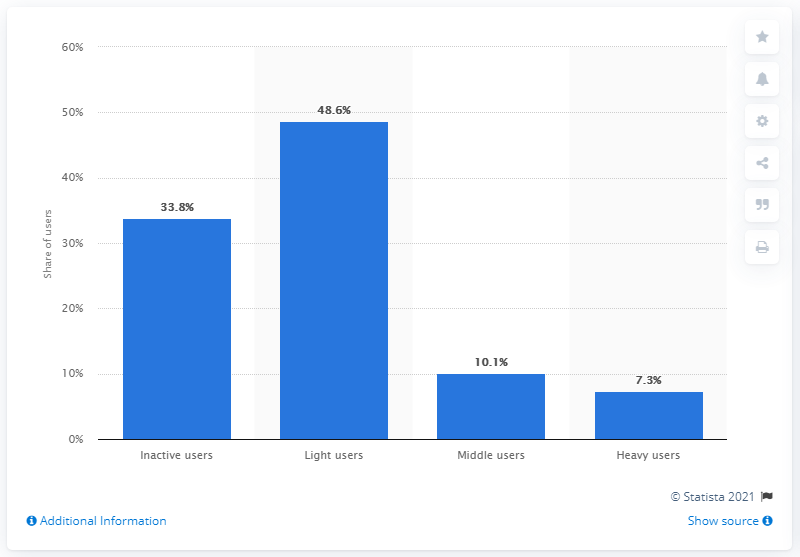Point out several critical features in this image. In the United States as of March 2021, approximately 7.3% of Pinterest users were considered heavy users. 